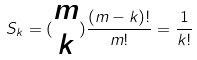<formula> <loc_0><loc_0><loc_500><loc_500>S _ { k } = ( \begin{matrix} m \\ k \end{matrix} ) \frac { ( m - k ) ! } { m ! } = \frac { 1 } { k ! }</formula> 